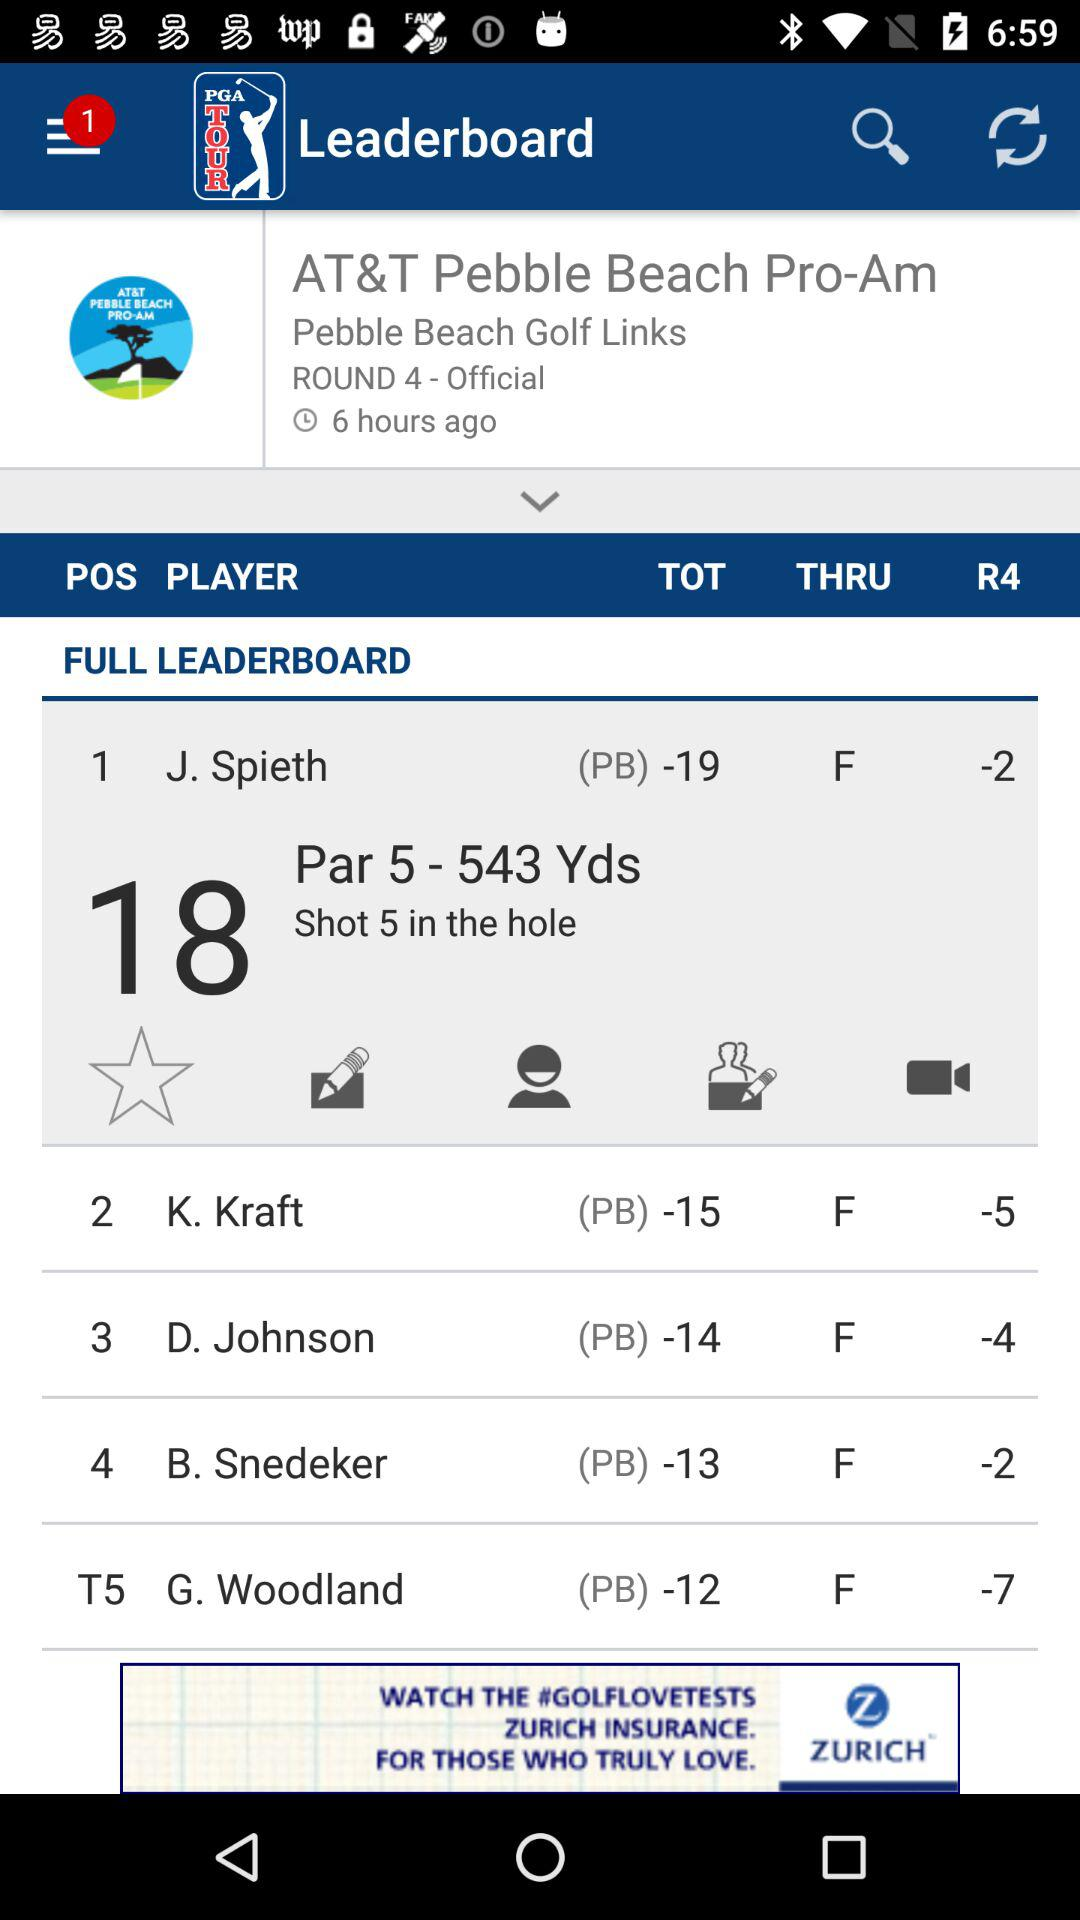How many rounds are there in the tournament?
Answer the question using a single word or phrase. 4 